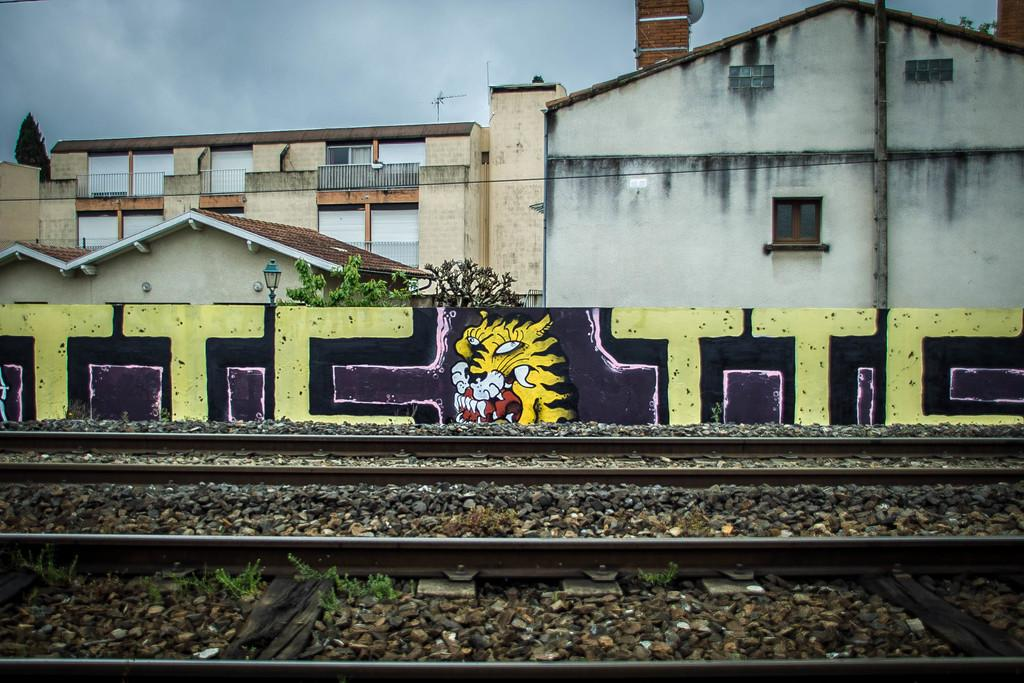What is the main feature of the image? There is a track in the image. What can be seen in the background of the image? In the background of the image, there is a fence, lights, trees, and buildings. What is visible at the top of the image? The sky is visible at the top of the image. What color are the eyes of the person holding the screw in the image? There is no person holding a screw in the image, as it only features a track, fence, lights, trees, buildings, and the sky. 